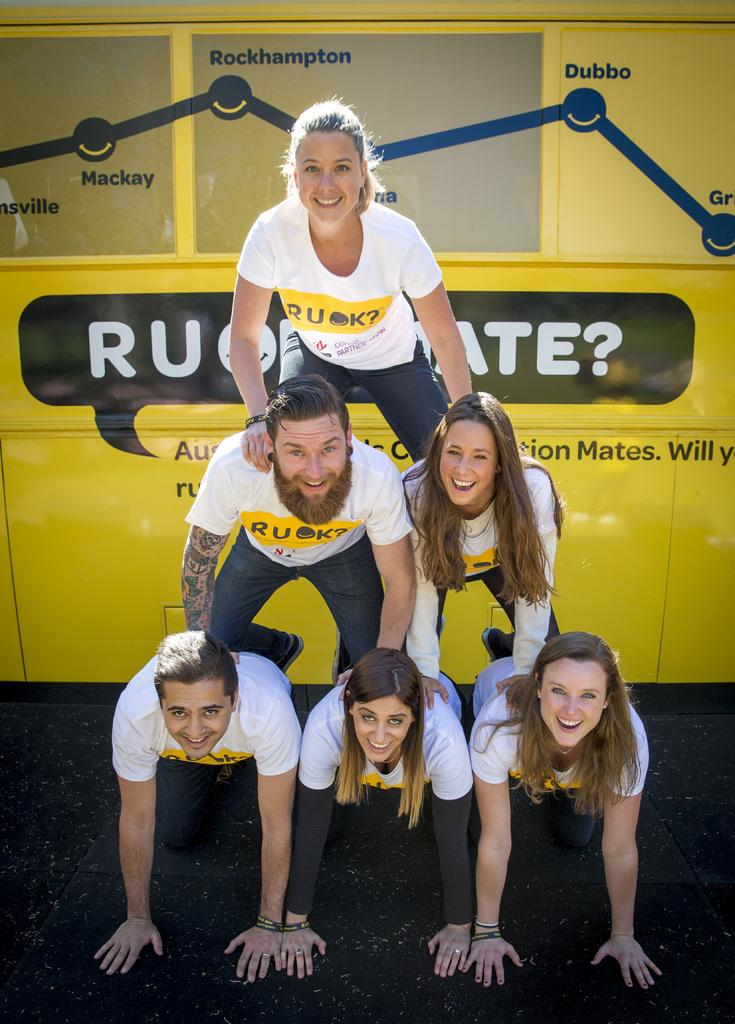<image>
Describe the image concisely. Girl wearing a white shirt which says RUOK. 